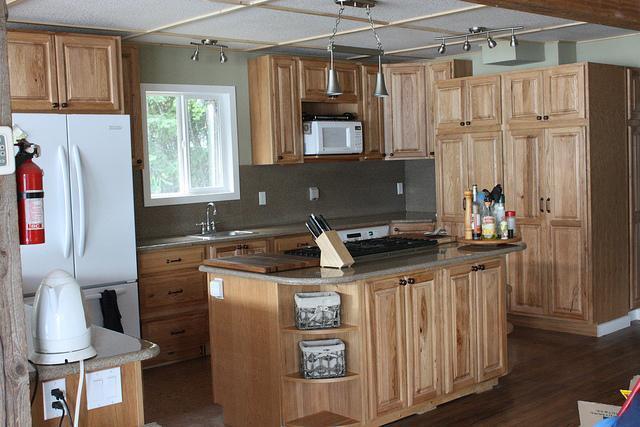How many microwaves can be seen?
Give a very brief answer. 1. How many people are wearing a yellow shirt?
Give a very brief answer. 0. 